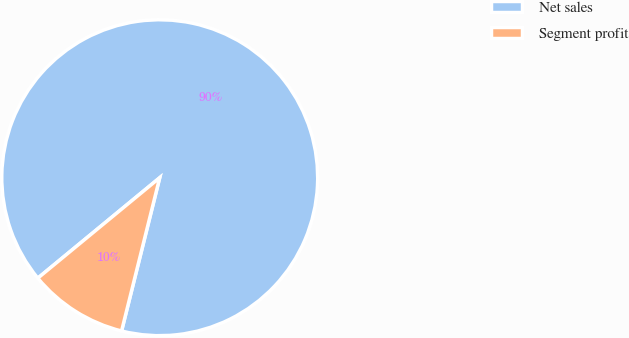<chart> <loc_0><loc_0><loc_500><loc_500><pie_chart><fcel>Net sales<fcel>Segment profit<nl><fcel>89.85%<fcel>10.15%<nl></chart> 